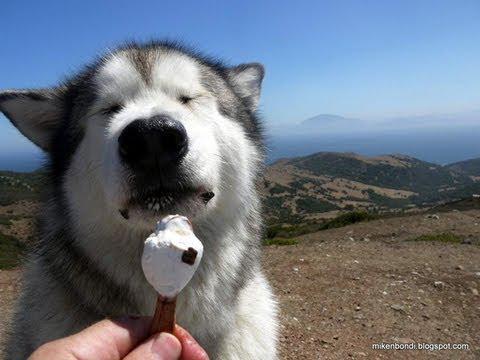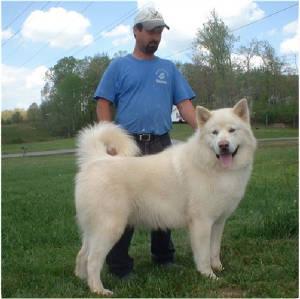The first image is the image on the left, the second image is the image on the right. For the images displayed, is the sentence "The left image shows  a hand offering white ice cream to a forward-facing husky dog." factually correct? Answer yes or no. Yes. 